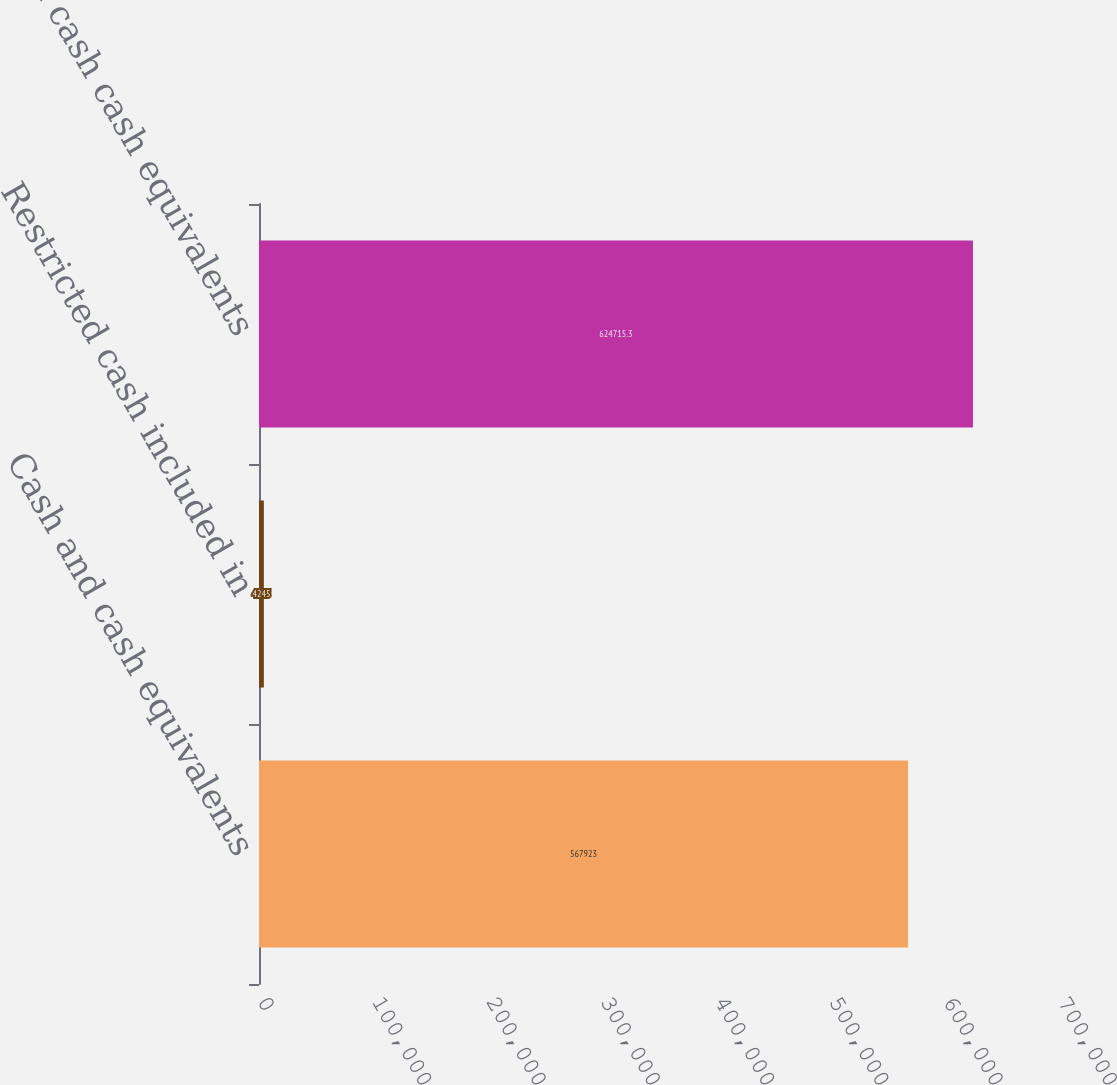<chart> <loc_0><loc_0><loc_500><loc_500><bar_chart><fcel>Cash and cash equivalents<fcel>Restricted cash included in<fcel>Total cash cash equivalents<nl><fcel>567923<fcel>4245<fcel>624715<nl></chart> 